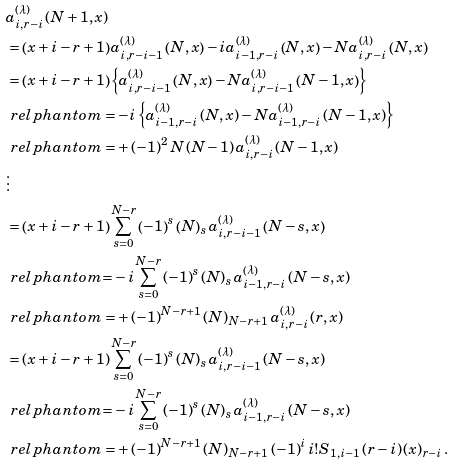Convert formula to latex. <formula><loc_0><loc_0><loc_500><loc_500>& a _ { i , r - i } ^ { \left ( \lambda \right ) } \left ( N + 1 , x \right ) \\ & = \left ( x + i - r + 1 \right ) a _ { i , r - i - 1 } ^ { \left ( \lambda \right ) } \left ( N , x \right ) - i a _ { i - 1 , r - i } ^ { \left ( \lambda \right ) } \left ( N , x \right ) - N a _ { i , r - i } ^ { \left ( \lambda \right ) } \left ( N , x \right ) \\ & = \left ( x + i - r + 1 \right ) \left \{ a _ { i , r - i - 1 } ^ { \left ( \lambda \right ) } \left ( N , x \right ) - N a _ { i , r - i - 1 } ^ { \left ( \lambda \right ) } \left ( N - 1 , x \right ) \right \} \\ & \ r e l p h a n t o m = - i \left \{ a _ { i - 1 , r - i } ^ { \left ( \lambda \right ) } \left ( N , x \right ) - N a _ { i - 1 , r - i } ^ { \left ( \lambda \right ) } \left ( N - 1 , x \right ) \right \} \\ & \ r e l p h a n t o m = + \left ( - 1 \right ) ^ { 2 } N \left ( N - 1 \right ) a _ { i , r - i } ^ { \left ( \lambda \right ) } \left ( N - 1 , x \right ) \\ & \vdots \\ & = \left ( x + i - r + 1 \right ) \sum _ { s = 0 } ^ { N - r } \left ( - 1 \right ) ^ { s } \left ( N \right ) _ { s } a _ { i , r - i - 1 } ^ { \left ( \lambda \right ) } \left ( N - s , x \right ) \\ & \ r e l p h a n t o m { = } - i \sum _ { s = 0 } ^ { N - r } \left ( - 1 \right ) ^ { s } \left ( N \right ) _ { s } a _ { i - 1 , r - i } ^ { \left ( \lambda \right ) } \left ( N - s , x \right ) \\ & \ r e l p h a n t o m = + \left ( - 1 \right ) ^ { N - r + 1 } \left ( N \right ) _ { N - r + 1 } a _ { i , r - i } ^ { \left ( \lambda \right ) } \left ( r , x \right ) \\ & = \left ( x + i - r + 1 \right ) \sum _ { s = 0 } ^ { N - r } \left ( - 1 \right ) ^ { s } \left ( N \right ) _ { s } a _ { i , r - i - 1 } ^ { \left ( \lambda \right ) } \left ( N - s , x \right ) \\ & \ r e l p h a n t o m { = } - i \sum _ { s = 0 } ^ { N - r } \left ( - 1 \right ) ^ { s } \left ( N \right ) _ { s } a _ { i - 1 , r - i } ^ { \left ( \lambda \right ) } \left ( N - s , x \right ) \\ & \ r e l p h a n t o m = + \left ( - 1 \right ) ^ { N - r + 1 } \left ( N \right ) _ { N - r + 1 } \left ( - 1 \right ) ^ { i } i ! S _ { 1 , i - 1 } \left ( r - i \right ) \left ( x \right ) _ { r - i } .</formula> 